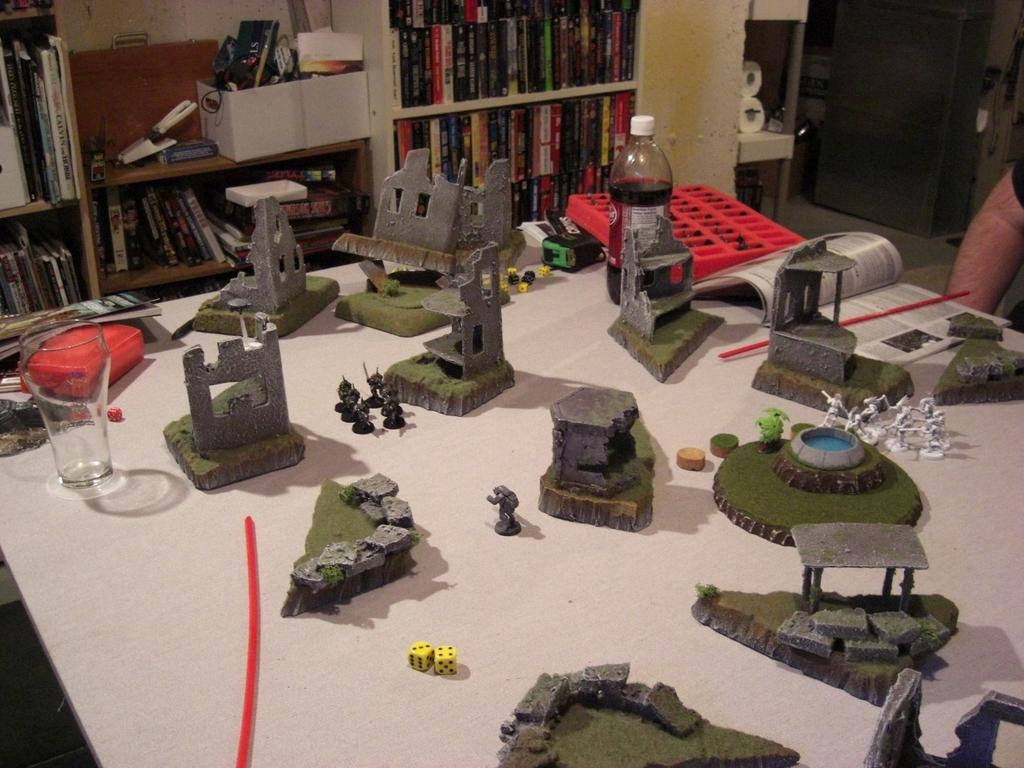What type of toys are present in the image? There are military toys in the image. Where are the military toys placed? The military toys are placed on a wooden table. What else can be seen in the image besides the military toys? There is a rack full of books visible in the image. What type of paper can be seen in the image? There is no paper present in the image; it features military toys on a wooden table and a rack full of books. What heart-related item is visible in the image? There is no heart-related item present in the image. 